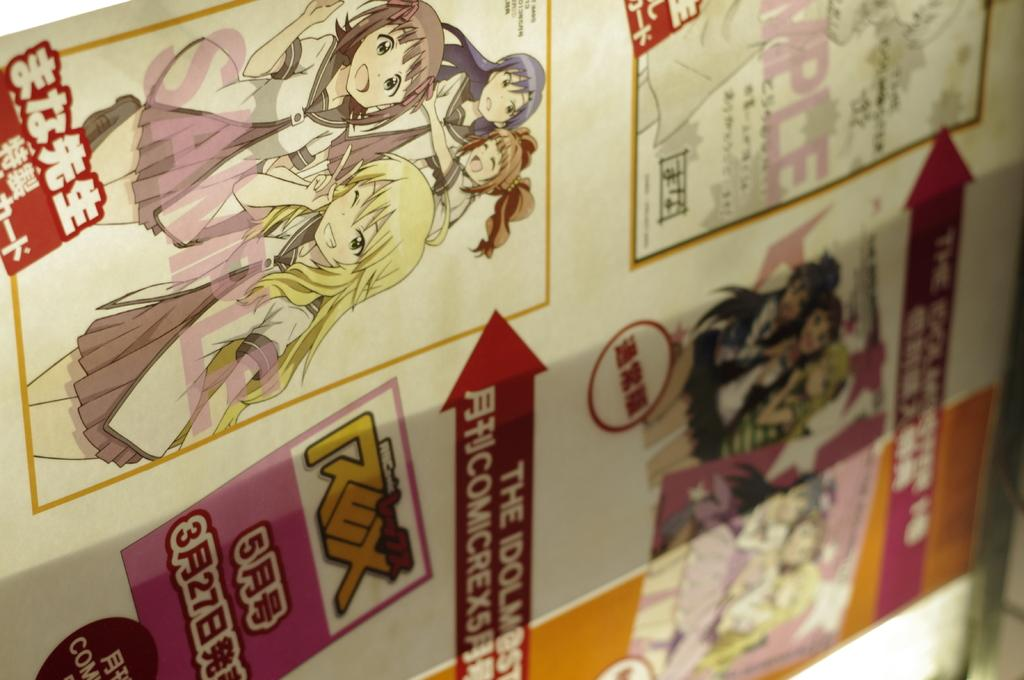What is the main subject of the image? The main subject of the image is a comic book. What type of cloth is used to cover the bedroom in the image? There is no mention of a bedroom or any cloth in the image; the image only contains a comic book. 